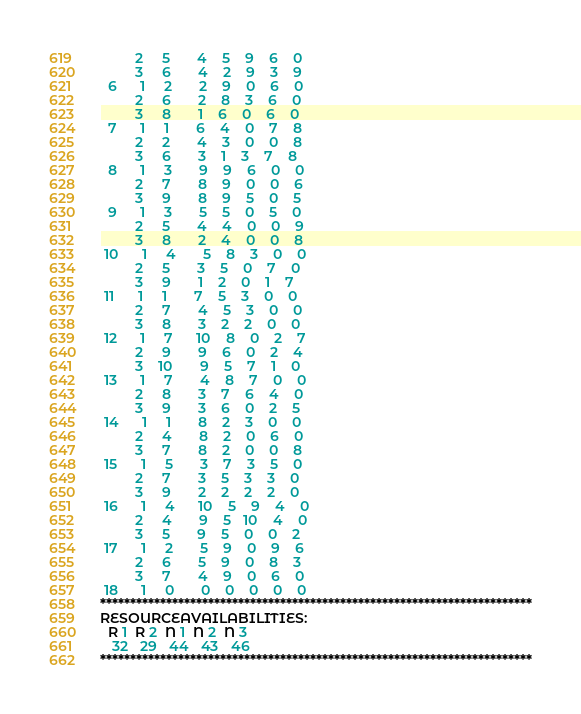Convert code to text. <code><loc_0><loc_0><loc_500><loc_500><_ObjectiveC_>         2     5       4    5    9    6    0
         3     6       4    2    9    3    9
  6      1     2       2    9    0    6    0
         2     6       2    8    3    6    0
         3     8       1    6    0    6    0
  7      1     1       6    4    0    7    8
         2     2       4    3    0    0    8
         3     6       3    1    3    7    8
  8      1     3       9    9    6    0    0
         2     7       8    9    0    0    6
         3     9       8    9    5    0    5
  9      1     3       5    5    0    5    0
         2     5       4    4    0    0    9
         3     8       2    4    0    0    8
 10      1     4       5    8    3    0    0
         2     5       3    5    0    7    0
         3     9       1    2    0    1    7
 11      1     1       7    5    3    0    0
         2     7       4    5    3    0    0
         3     8       3    2    2    0    0
 12      1     7      10    8    0    2    7
         2     9       9    6    0    2    4
         3    10       9    5    7    1    0
 13      1     7       4    8    7    0    0
         2     8       3    7    6    4    0
         3     9       3    6    0    2    5
 14      1     1       8    2    3    0    0
         2     4       8    2    0    6    0
         3     7       8    2    0    0    8
 15      1     5       3    7    3    5    0
         2     7       3    5    3    3    0
         3     9       2    2    2    2    0
 16      1     4      10    5    9    4    0
         2     4       9    5   10    4    0
         3     5       9    5    0    0    2
 17      1     2       5    9    0    9    6
         2     6       5    9    0    8    3
         3     7       4    9    0    6    0
 18      1     0       0    0    0    0    0
************************************************************************
RESOURCEAVAILABILITIES:
  R 1  R 2  N 1  N 2  N 3
   32   29   44   43   46
************************************************************************
</code> 